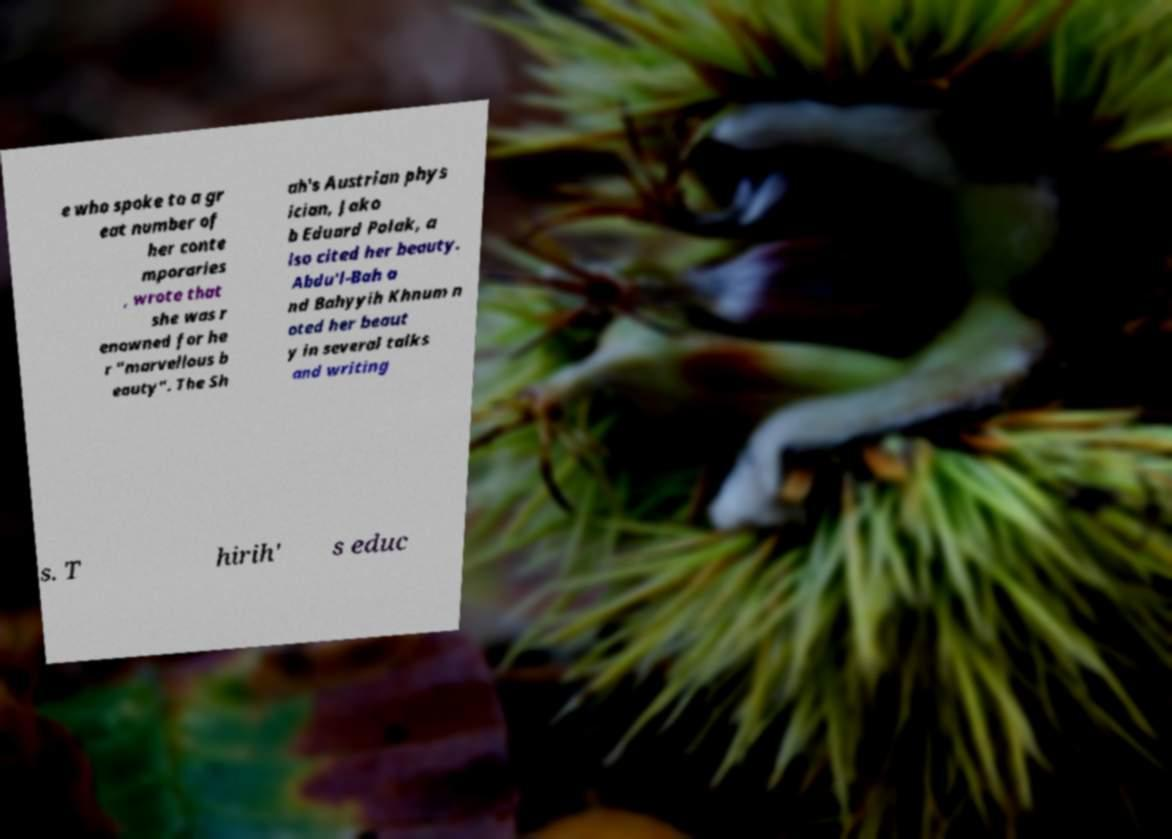What messages or text are displayed in this image? I need them in a readable, typed format. e who spoke to a gr eat number of her conte mporaries , wrote that she was r enowned for he r "marvellous b eauty". The Sh ah's Austrian phys ician, Jako b Eduard Polak, a lso cited her beauty. Abdu'l-Bah a nd Bahyyih Khnum n oted her beaut y in several talks and writing s. T hirih' s educ 